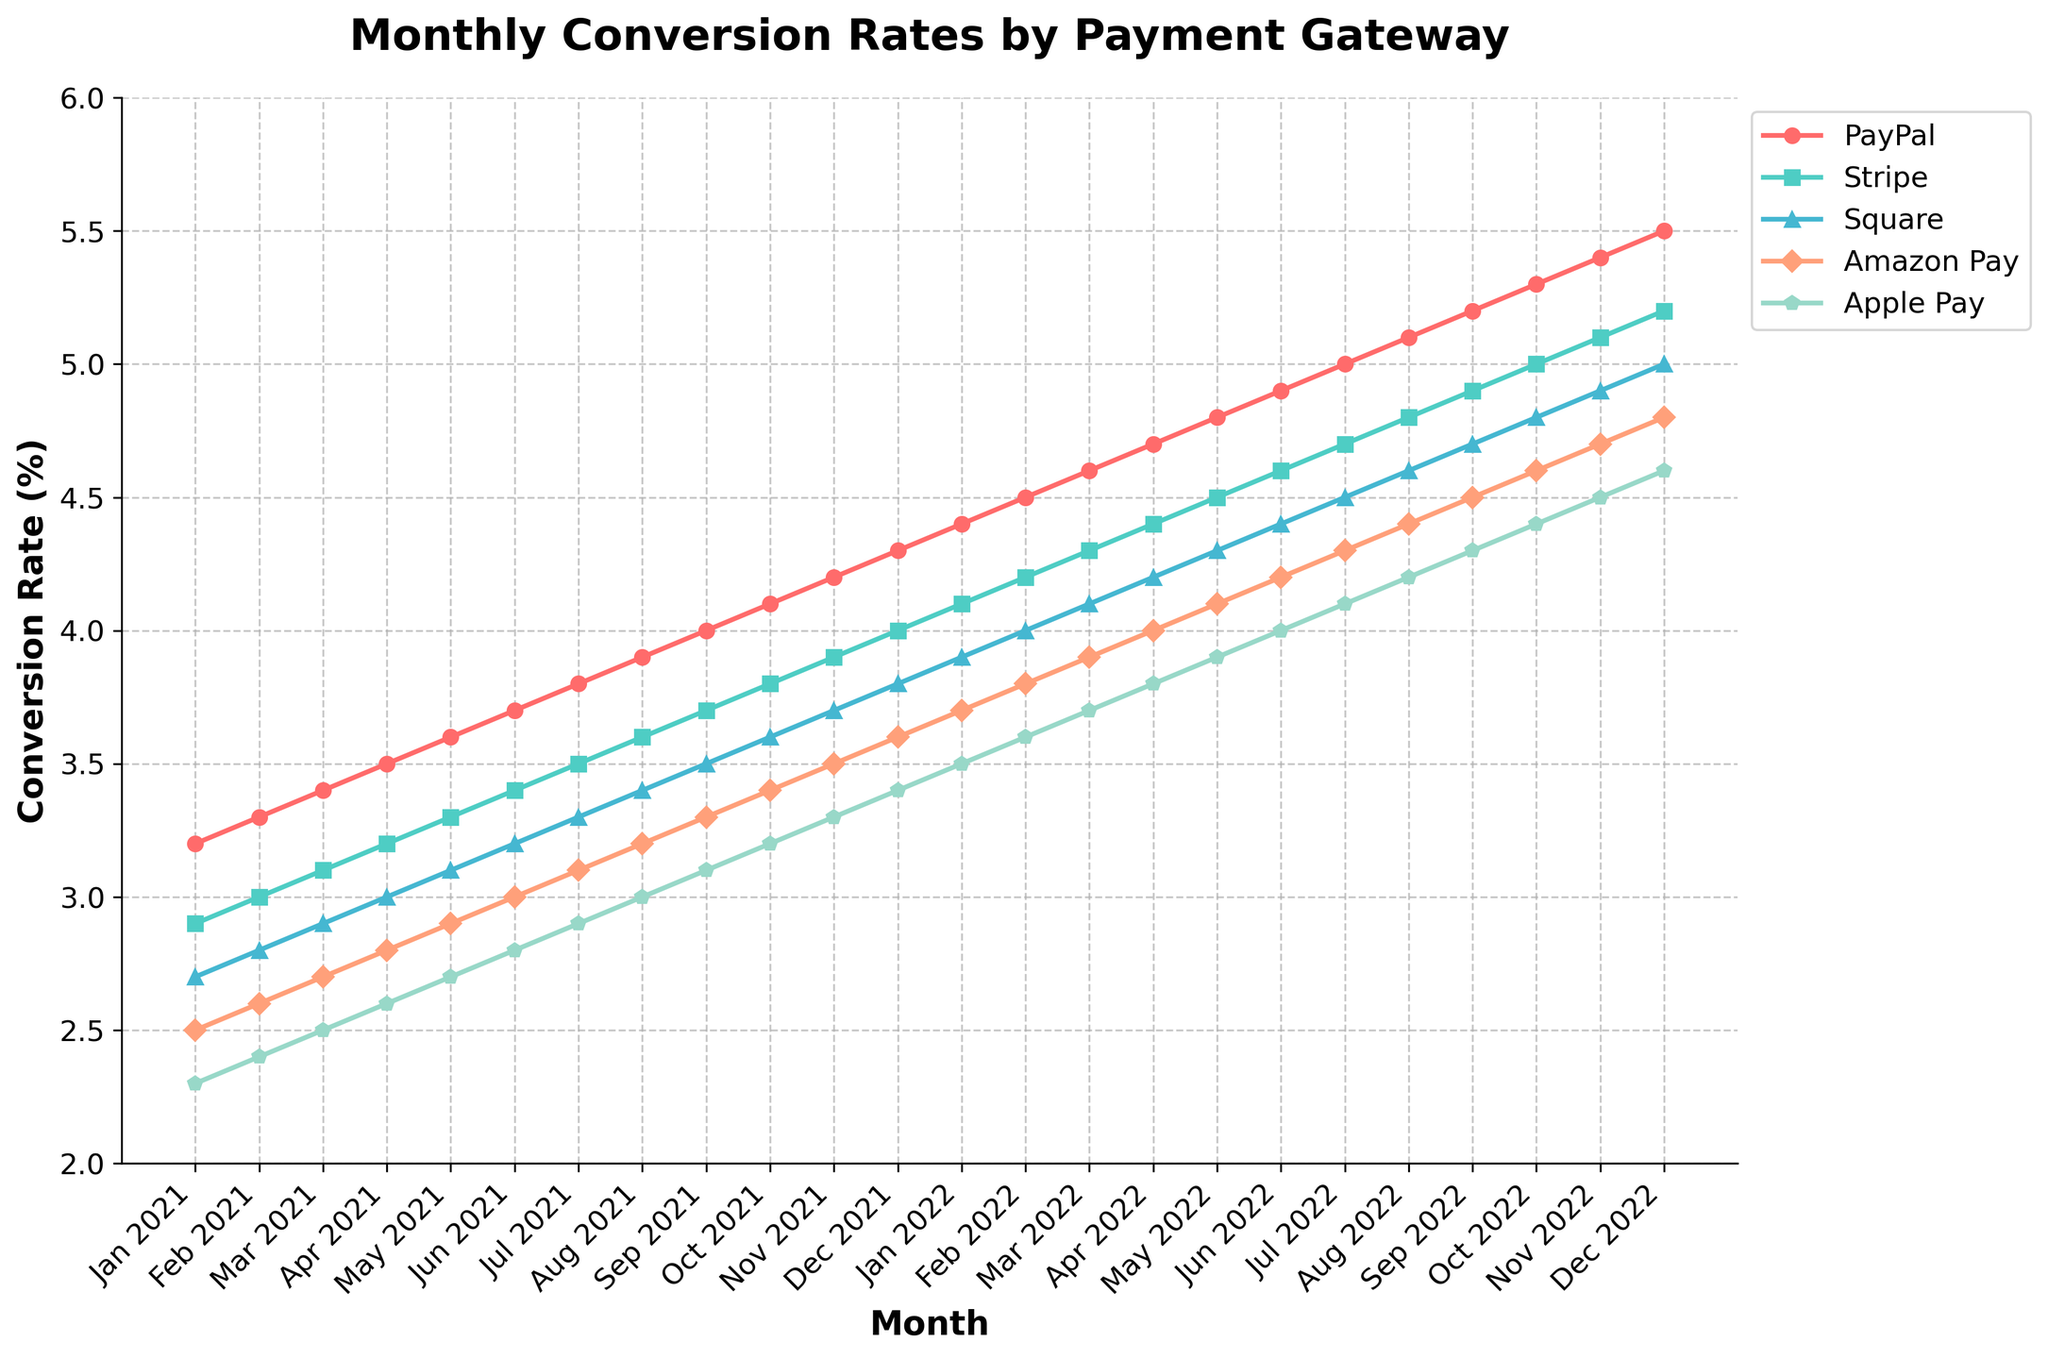What is the highest conversion rate recorded for PayPal over the two-year period? The highest conversion rate for PayPal is seen at the end of the period. From the chart, this value is observed in December 2022.
Answer: 5.5% Which payment gateway had the lowest conversion rate in February 2021? Each payment gateway's conversion rate is plotted monthly. In February 2021, the lowest conversion rate is for Apple Pay at 2.4%.
Answer: Apple Pay Did Stripe ever have a higher conversion rate than PayPal? To determine if Stripe had a higher conversion rate than PayPal at any point, we need to examine if any of Stripe's values surpass PayPal's in the line chart. Throughout the period, PayPal's rates are consistently higher than Stripe's.
Answer: No What is the average conversion rate of Square in 2021? To find the average, sum Square's monthly conversion rates for 2021 and divide by the number of months. (2.7+2.8+2.9+3.0+3.1+3.2+3.3+3.4+3.5+3.6+3.7+3.8)/12 = 3.2%.
Answer: 3.2% By how much did Amazon Pay's conversion rate increase from Jan 2021 to Dec 2022? Calculate the difference in Amazon Pay's conversion rate between January 2021 and December 2022. 4.8 (Dec 2022) - 2.5 (Jan 2021) = 2.3%.
Answer: 2.3% Which month in 2022 has the smallest difference between the conversion rates of PayPal and Stripe? For each month in 2022, subtract Stripe’s conversion rate from PayPal's rate. The smallest difference observed is in October 2022 (5.3 - 5.0 = 0.3).
Answer: October 2022 What trend can you observe in Apple Pay's conversion rate throughout the two-year period? Apple Pay's conversion rate consistently increases month by month as illustrated by its upward line on the chart.
Answer: Increasing How much higher is PayPal's conversion rate compared to Apple Pay's in June 2022? Subtract Apple Pay's June 2022 conversion rate from PayPal's rate. 4.9 (PayPal) - 4.0 (Apple Pay) = 0.9%.
Answer: 0.9% Which payment gateway showed the steadiest increase in conversion rate over the two years? Compare the slopes of the lines representing each payment gateway. PayPal’s line increases most uniformly without significant fluctuations.
Answer: PayPal What is the total increase in conversion rate for Stripe from Jan 2021 to Dec 2022? Calculate the difference between Stripe's conversion rate in December 2022 and January 2021. 5.2 (Dec 2022) - 2.9 (Jan 2021) = 2.3%.
Answer: 2.3% 